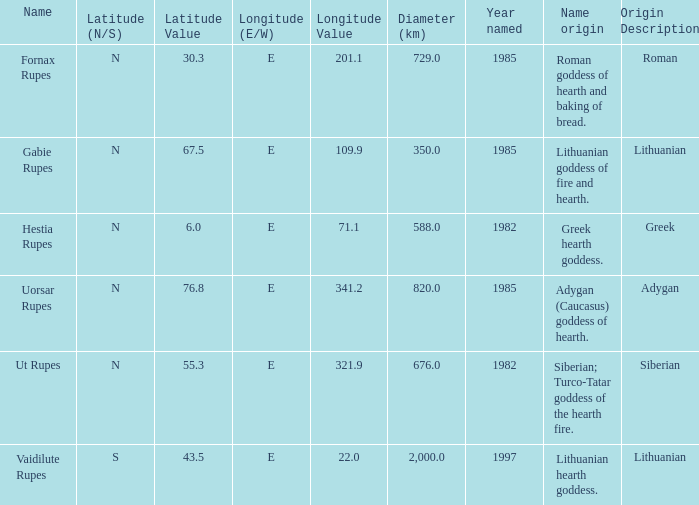For features at a 321.9-degree east longitude, what latitude can be observed? 55.3N. 